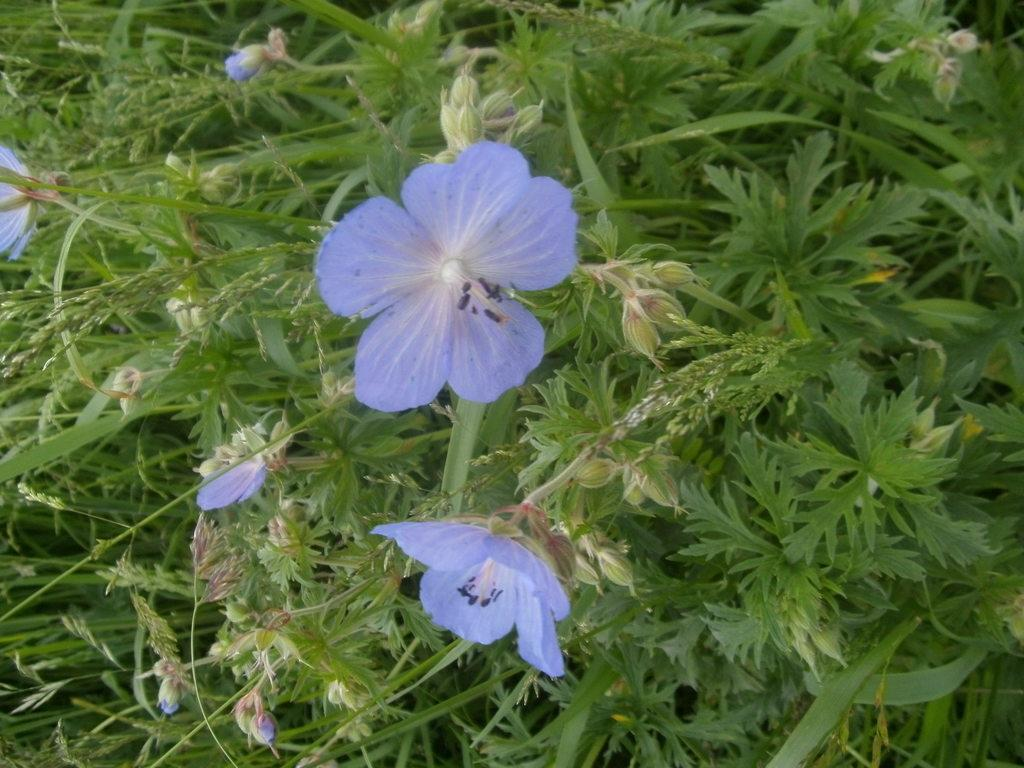What is the main subject of the image? The main subject of the image is a plant. What specific part of the plant is the focus of the image? The image is a zoomed-in view of the plant, focusing on the flowers. What color are the flowers in the image? The flowers in the image are purple in color. What time does the clock in the image show? There is no clock present in the image; it is a zoomed-in view of a plant with purple flowers. 